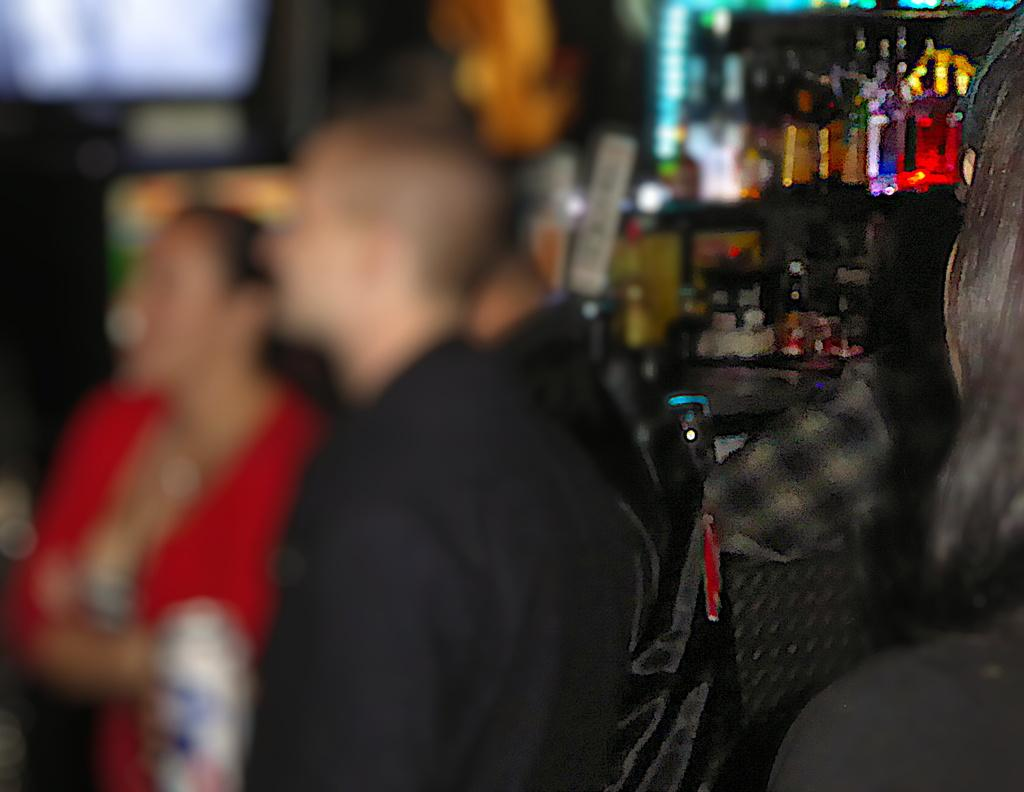How many people are in the image? There are people in the image, but the exact number is not specified. What can be seen in the background of the image? There are lights visible in the background of the image. What type of objects are present in the image? There are bottles in the image. Can you see any mountains or trails in the image? There is no mention of mountains or trails in the image; only people, lights, and bottles are present. Are there any waves visible in the image? There is no mention of waves in the image; only people, lights, and bottles are present. 